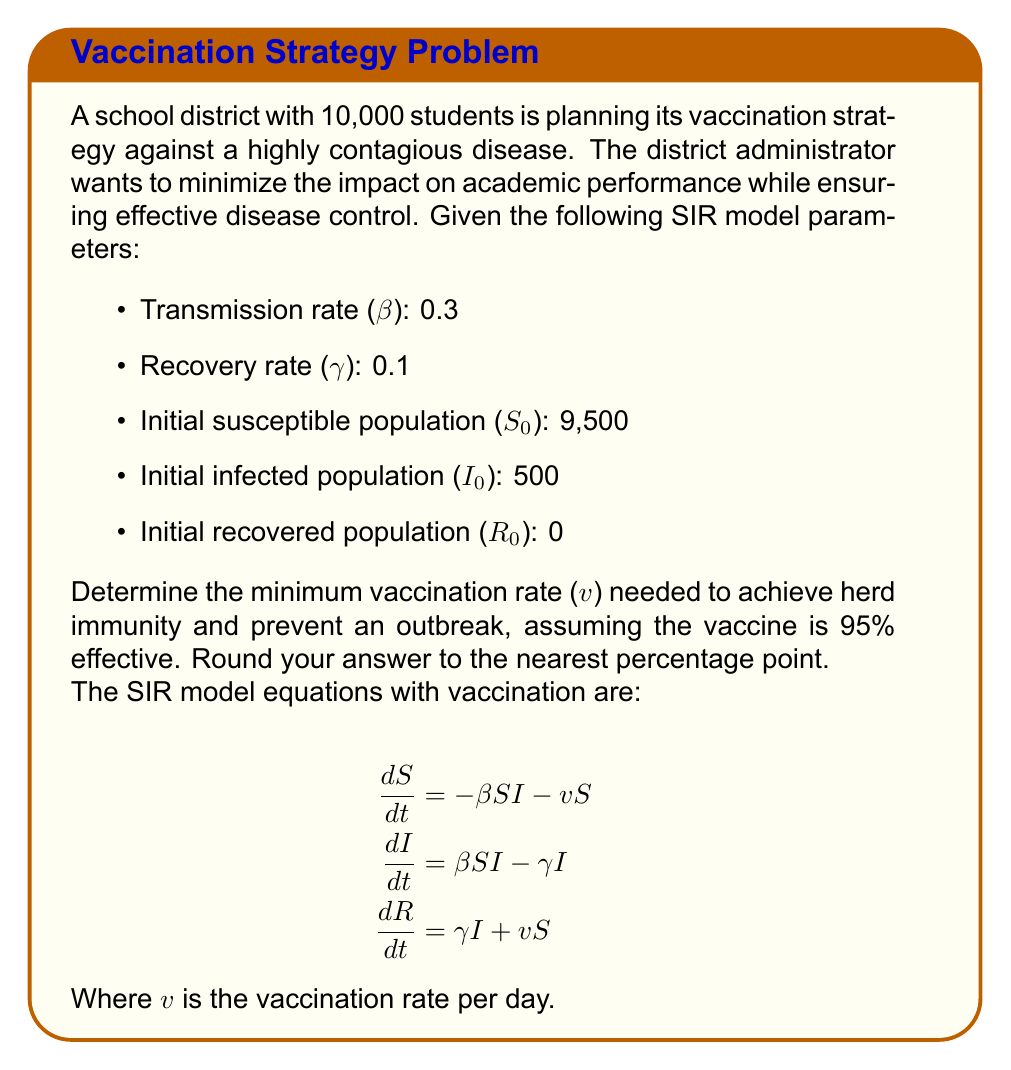Can you solve this math problem? To determine the minimum vaccination rate for herd immunity, we need to calculate the basic reproduction number (R₀) and use it to find the herd immunity threshold.

Step 1: Calculate the basic reproduction number (R₀)
R₀ = β / γ = 0.3 / 0.1 = 3

Step 2: Calculate the herd immunity threshold (H)
H = 1 - 1/R₀ = 1 - 1/3 ≈ 0.6667 or 66.67%

Step 3: Account for vaccine effectiveness
Since the vaccine is 95% effective, we need to adjust the herd immunity threshold:
Adjusted H = H / 0.95 ≈ 0.7018 or 70.18%

Step 4: Calculate the minimum vaccination rate
To achieve herd immunity, we need to vaccinate at least 70.18% of the susceptible population.

Minimum vaccination rate = 0.7018 * 9,500 / 10,000 ≈ 0.6667 or 66.67%

Step 5: Round to the nearest percentage point
Rounded minimum vaccination rate = 67%

Therefore, the school district needs to vaccinate at least 67% of the total student population to achieve herd immunity and prevent an outbreak while minimizing disruption to academic activities.
Answer: 67% 